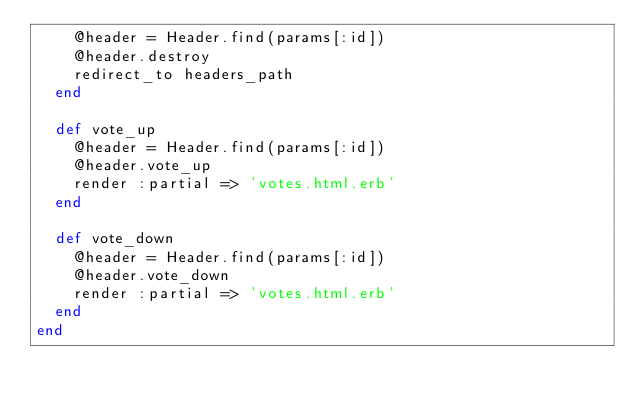<code> <loc_0><loc_0><loc_500><loc_500><_Ruby_>    @header = Header.find(params[:id])
    @header.destroy
    redirect_to headers_path
  end
  
  def vote_up
    @header = Header.find(params[:id])
    @header.vote_up
    render :partial => 'votes.html.erb'
  end
  
  def vote_down
    @header = Header.find(params[:id])
    @header.vote_down
    render :partial => 'votes.html.erb'
  end  
end
</code> 